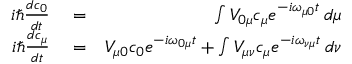<formula> <loc_0><loc_0><loc_500><loc_500>\begin{array} { r l r } { i \hbar { } d c _ { 0 } } { d t } } & = } & { \int V _ { 0 \mu } c _ { \mu } e ^ { - i \omega _ { \mu 0 } t } \, d \mu } \\ { i \hbar { } d c _ { \mu } } { d t } } & = } & { V _ { \mu 0 } c _ { 0 } e ^ { - i \omega _ { 0 \mu } t } + \int V _ { \mu \nu } c _ { \mu } e ^ { - i \omega _ { \nu \mu } t } \, d \nu } \end{array}</formula> 